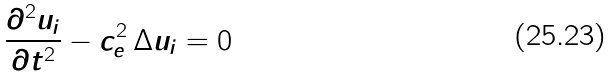Convert formula to latex. <formula><loc_0><loc_0><loc_500><loc_500>\frac { \partial ^ { 2 } u _ { i } } { \partial t ^ { 2 } } - c _ { e } ^ { 2 } \, \Delta u _ { i } = 0</formula> 